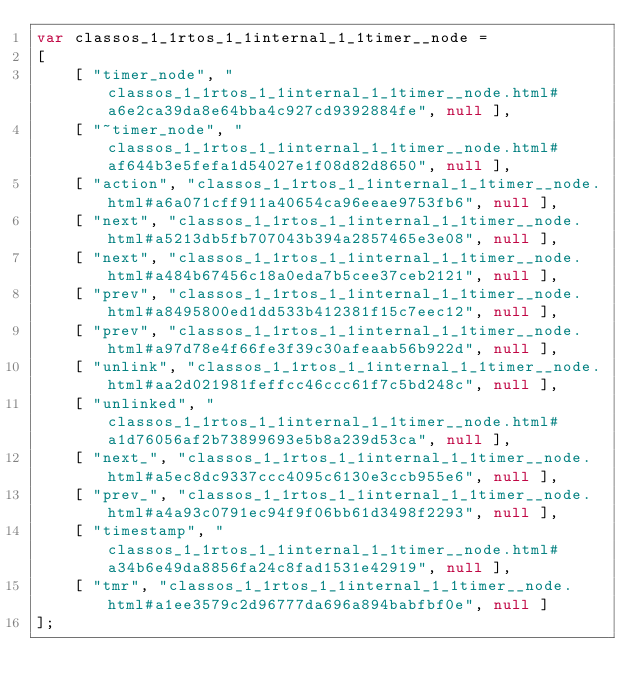Convert code to text. <code><loc_0><loc_0><loc_500><loc_500><_JavaScript_>var classos_1_1rtos_1_1internal_1_1timer__node =
[
    [ "timer_node", "classos_1_1rtos_1_1internal_1_1timer__node.html#a6e2ca39da8e64bba4c927cd9392884fe", null ],
    [ "~timer_node", "classos_1_1rtos_1_1internal_1_1timer__node.html#af644b3e5fefa1d54027e1f08d82d8650", null ],
    [ "action", "classos_1_1rtos_1_1internal_1_1timer__node.html#a6a071cff911a40654ca96eeae9753fb6", null ],
    [ "next", "classos_1_1rtos_1_1internal_1_1timer__node.html#a5213db5fb707043b394a2857465e3e08", null ],
    [ "next", "classos_1_1rtos_1_1internal_1_1timer__node.html#a484b67456c18a0eda7b5cee37ceb2121", null ],
    [ "prev", "classos_1_1rtos_1_1internal_1_1timer__node.html#a8495800ed1dd533b412381f15c7eec12", null ],
    [ "prev", "classos_1_1rtos_1_1internal_1_1timer__node.html#a97d78e4f66fe3f39c30afeaab56b922d", null ],
    [ "unlink", "classos_1_1rtos_1_1internal_1_1timer__node.html#aa2d021981feffcc46ccc61f7c5bd248c", null ],
    [ "unlinked", "classos_1_1rtos_1_1internal_1_1timer__node.html#a1d76056af2b73899693e5b8a239d53ca", null ],
    [ "next_", "classos_1_1rtos_1_1internal_1_1timer__node.html#a5ec8dc9337ccc4095c6130e3ccb955e6", null ],
    [ "prev_", "classos_1_1rtos_1_1internal_1_1timer__node.html#a4a93c0791ec94f9f06bb61d3498f2293", null ],
    [ "timestamp", "classos_1_1rtos_1_1internal_1_1timer__node.html#a34b6e49da8856fa24c8fad1531e42919", null ],
    [ "tmr", "classos_1_1rtos_1_1internal_1_1timer__node.html#a1ee3579c2d96777da696a894babfbf0e", null ]
];</code> 